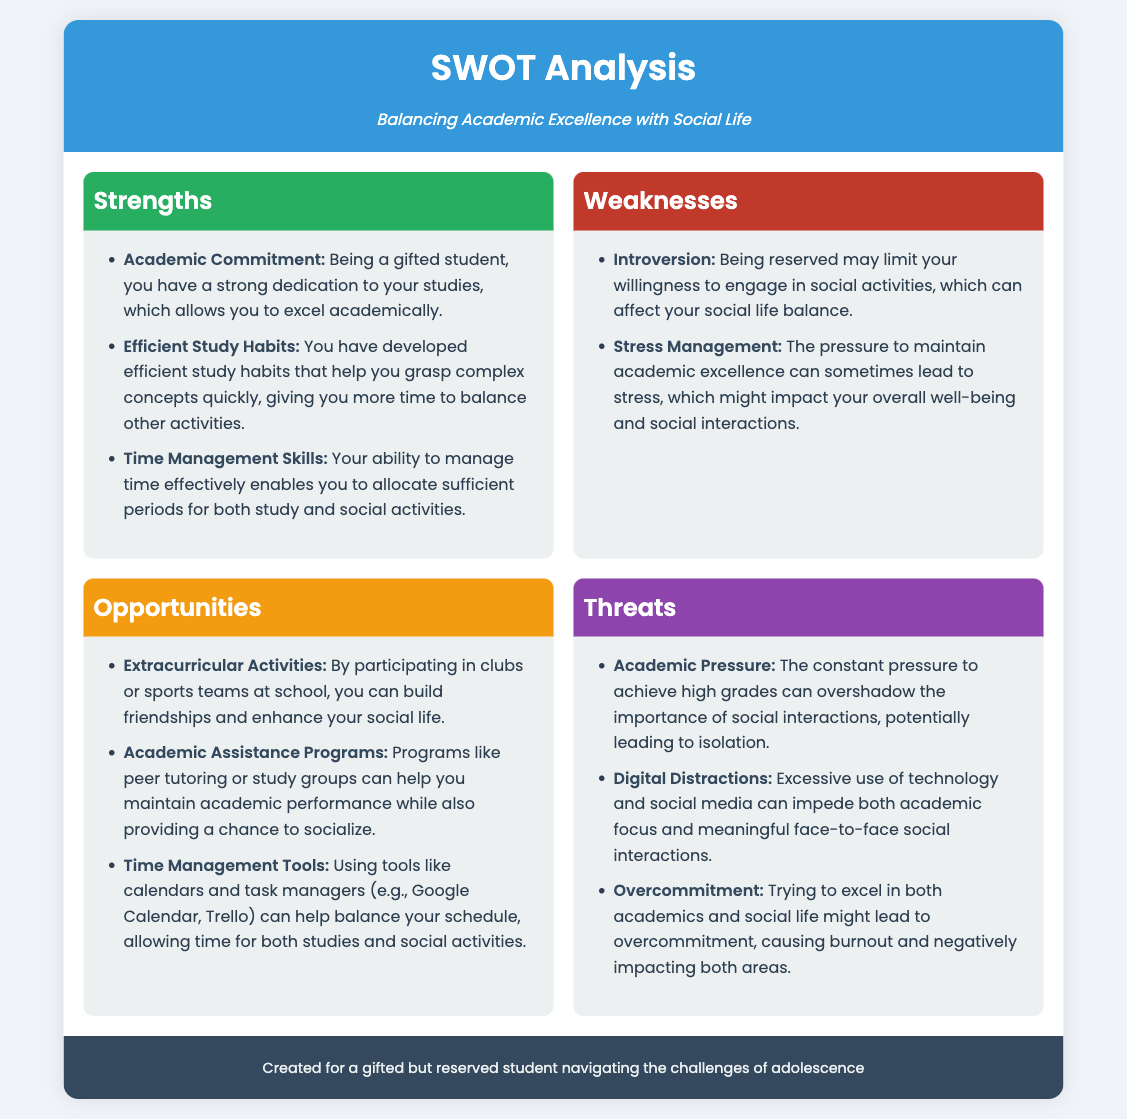What are the strengths listed in the SWOT analysis? The strengths are identified within the document as specific points mentioned under the "Strengths" section, which includes "Academic Commitment," "Efficient Study Habits," and "Time Management Skills."
Answer: Academic Commitment, Efficient Study Habits, Time Management Skills What is one weakness related to social life mentioned? The weaknesses highlighted in the SWOT analysis include "Introversion," which indicates that being reserved limits social engagement.
Answer: Introversion What opportunity involves extracurricular activities? One of the opportunities presented in the analysis is related to participation in "Extracurricular Activities," which can enhance social life and friendship building.
Answer: Extracurricular Activities What threat is associated with excessive technology use? The document outlines "Digital Distractions" as a threat that can impede academic focus and meaningful social interactions.
Answer: Digital Distractions How many strengths are listed in the analysis? The "Strengths" section contains a total of three specific strengths mentioned in the document relating to academic excellence and time management.
Answer: 3 Which time management tools are suggested? The document specifically mentions "calendars and task managers" as tools that can aid in balancing studies and social activities effectively.
Answer: calendars and task managers What is a key aspect of academic pressure mentioned? The analysis highlights that "Academic Pressure" can overshadow social interactions, indicating its significant impact on student life.
Answer: Academic Pressure What does overcommitment lead to, according to the analysis? The document warns that "Overcommitment" might lead to burnout, negatively impacting both academic and social spheres.
Answer: burnout 